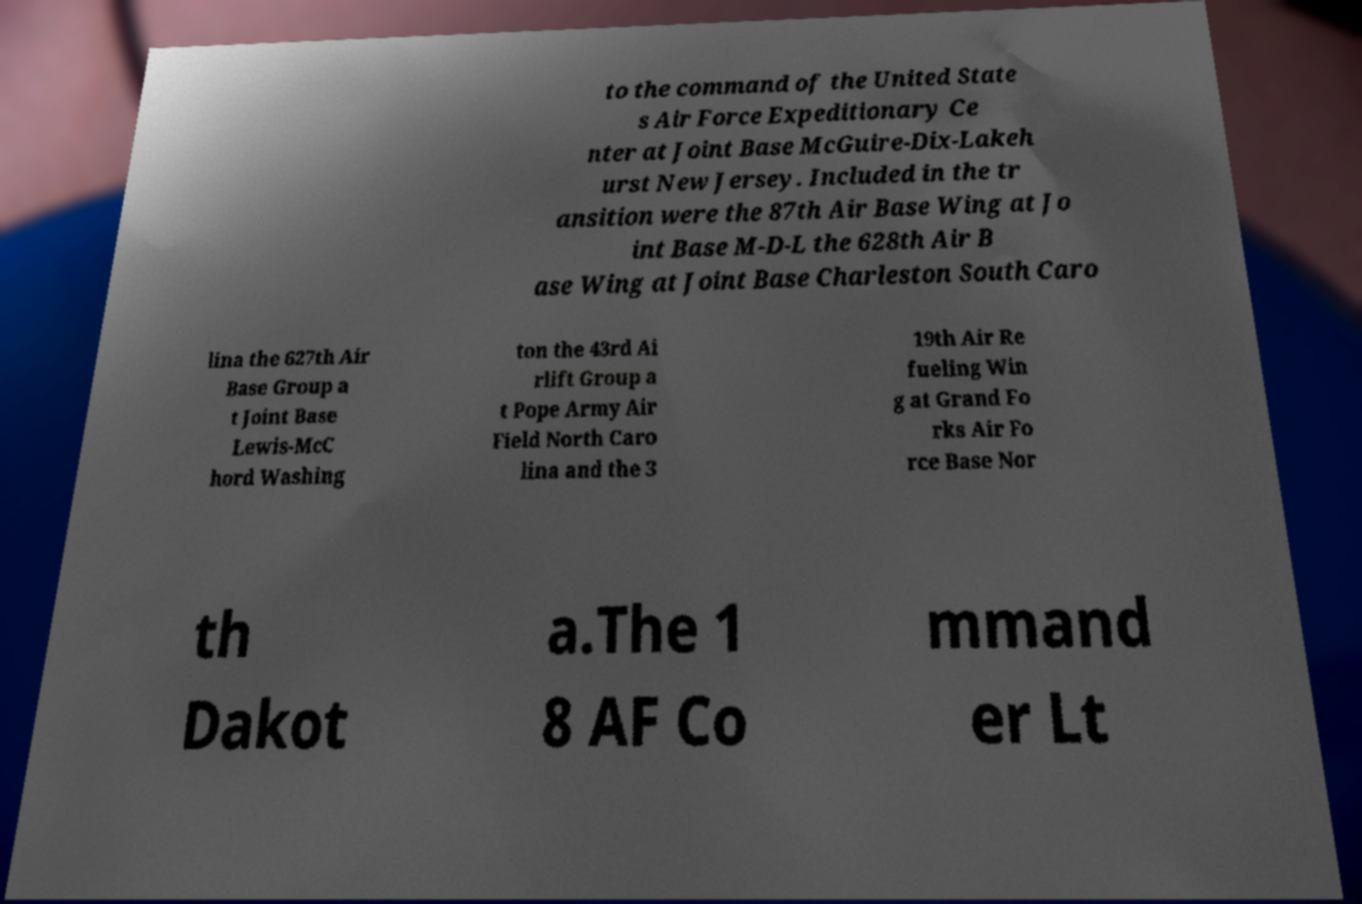For documentation purposes, I need the text within this image transcribed. Could you provide that? to the command of the United State s Air Force Expeditionary Ce nter at Joint Base McGuire-Dix-Lakeh urst New Jersey. Included in the tr ansition were the 87th Air Base Wing at Jo int Base M-D-L the 628th Air B ase Wing at Joint Base Charleston South Caro lina the 627th Air Base Group a t Joint Base Lewis-McC hord Washing ton the 43rd Ai rlift Group a t Pope Army Air Field North Caro lina and the 3 19th Air Re fueling Win g at Grand Fo rks Air Fo rce Base Nor th Dakot a.The 1 8 AF Co mmand er Lt 